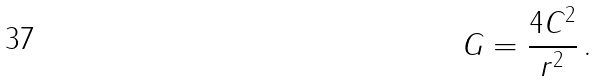Convert formula to latex. <formula><loc_0><loc_0><loc_500><loc_500>G = \frac { 4 C ^ { 2 } } { r ^ { 2 } } \, .</formula> 